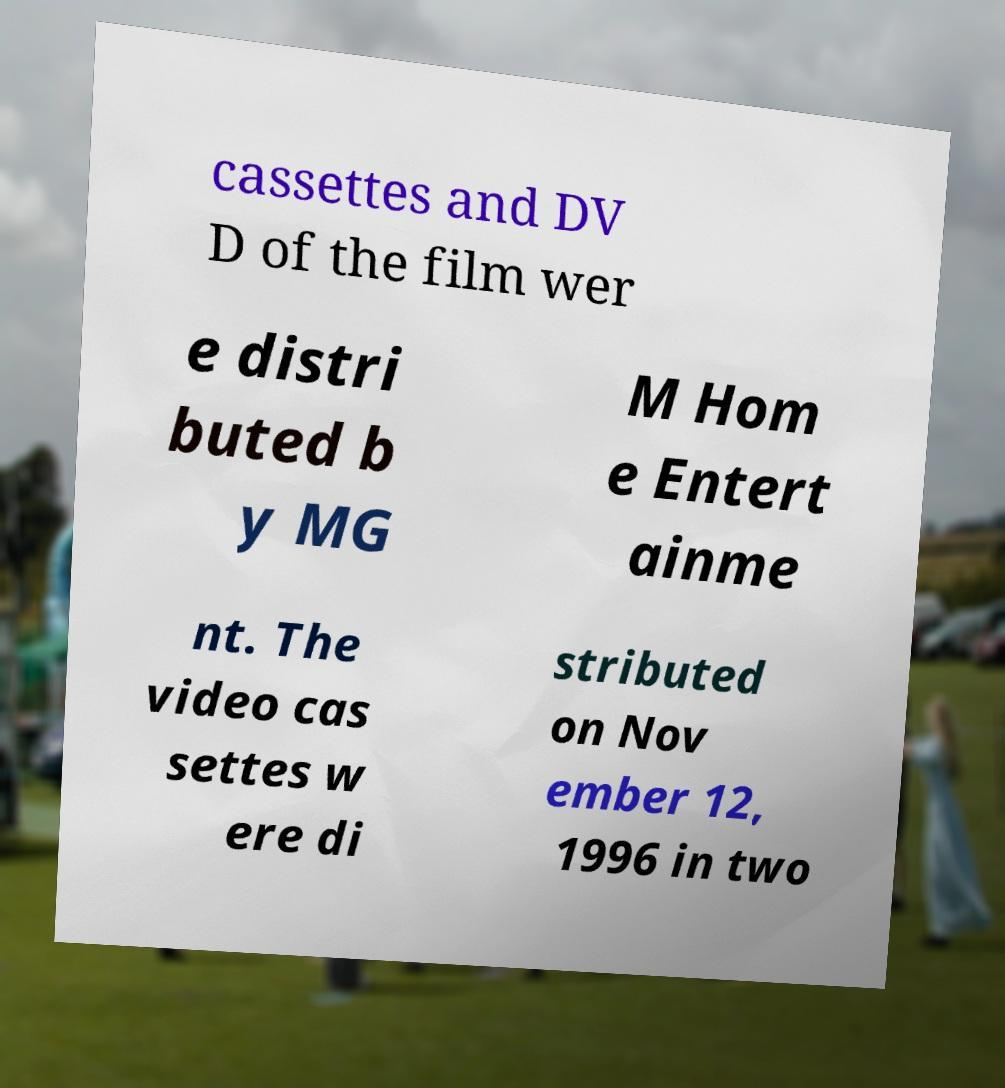I need the written content from this picture converted into text. Can you do that? cassettes and DV D of the film wer e distri buted b y MG M Hom e Entert ainme nt. The video cas settes w ere di stributed on Nov ember 12, 1996 in two 